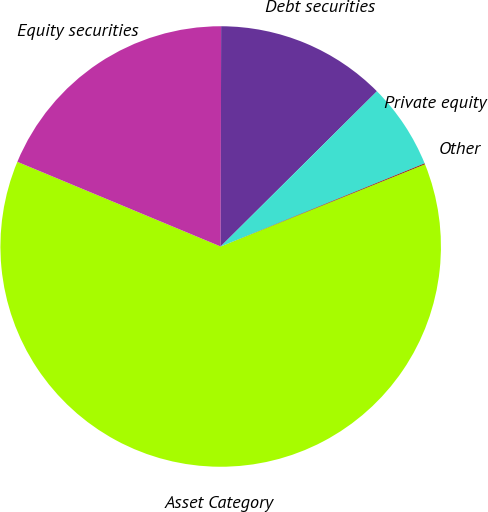<chart> <loc_0><loc_0><loc_500><loc_500><pie_chart><fcel>Asset Category<fcel>Equity securities<fcel>Debt securities<fcel>Private equity<fcel>Other<nl><fcel>62.37%<fcel>18.75%<fcel>12.52%<fcel>6.29%<fcel>0.06%<nl></chart> 